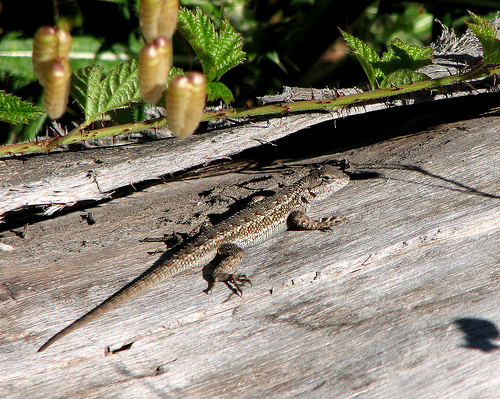<image>
Is the lizard under the vine? Yes. The lizard is positioned underneath the vine, with the vine above it in the vertical space. 